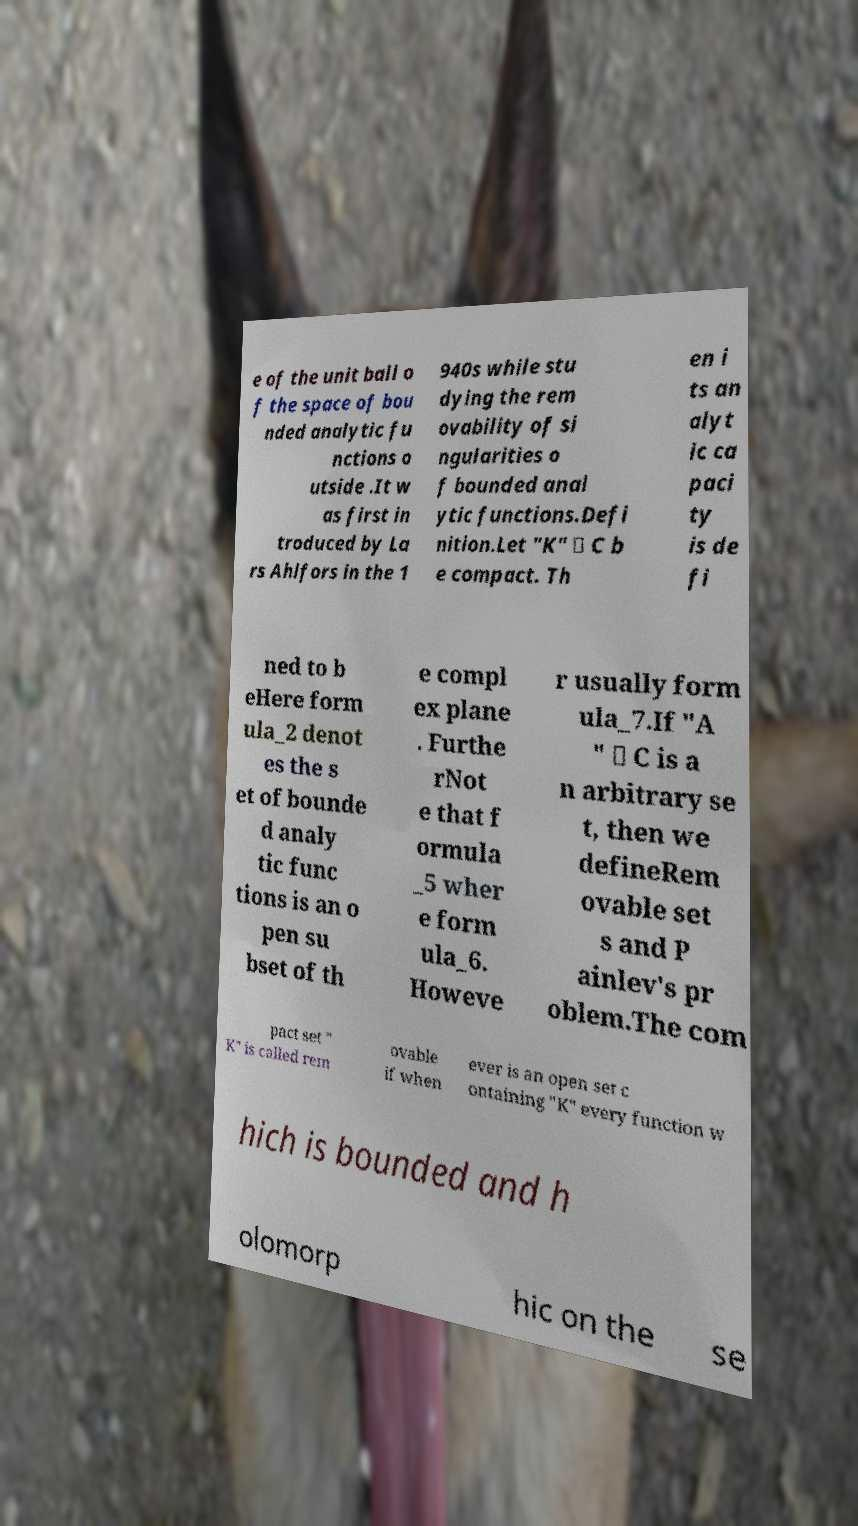There's text embedded in this image that I need extracted. Can you transcribe it verbatim? e of the unit ball o f the space of bou nded analytic fu nctions o utside .It w as first in troduced by La rs Ahlfors in the 1 940s while stu dying the rem ovability of si ngularities o f bounded anal ytic functions.Defi nition.Let "K" ⊂ C b e compact. Th en i ts an alyt ic ca paci ty is de fi ned to b eHere form ula_2 denot es the s et of bounde d analy tic func tions is an o pen su bset of th e compl ex plane . Furthe rNot e that f ormula _5 wher e form ula_6. Howeve r usually form ula_7.If "A " ⊂ C is a n arbitrary se t, then we defineRem ovable set s and P ainlev's pr oblem.The com pact set " K" is called rem ovable if when ever is an open set c ontaining "K" every function w hich is bounded and h olomorp hic on the se 